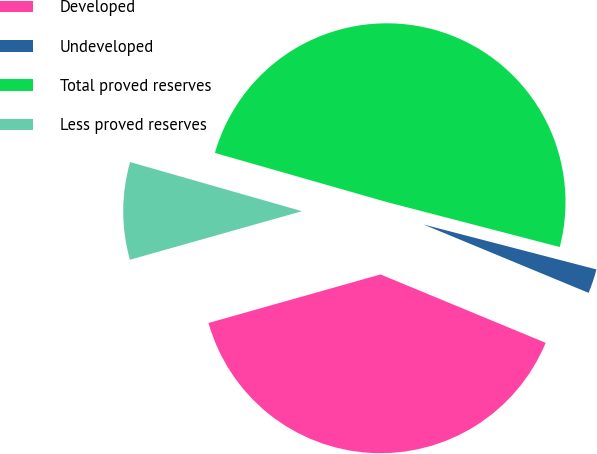Convert chart. <chart><loc_0><loc_0><loc_500><loc_500><pie_chart><fcel>Developed<fcel>Undeveloped<fcel>Total proved reserves<fcel>Less proved reserves<nl><fcel>39.37%<fcel>2.2%<fcel>49.61%<fcel>8.81%<nl></chart> 